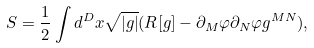<formula> <loc_0><loc_0><loc_500><loc_500>S = \frac { 1 } { 2 } \int d ^ { D } x \sqrt { | g | } ( { R } [ g ] - \partial _ { M } \varphi \partial _ { N } \varphi g ^ { M N } ) ,</formula> 